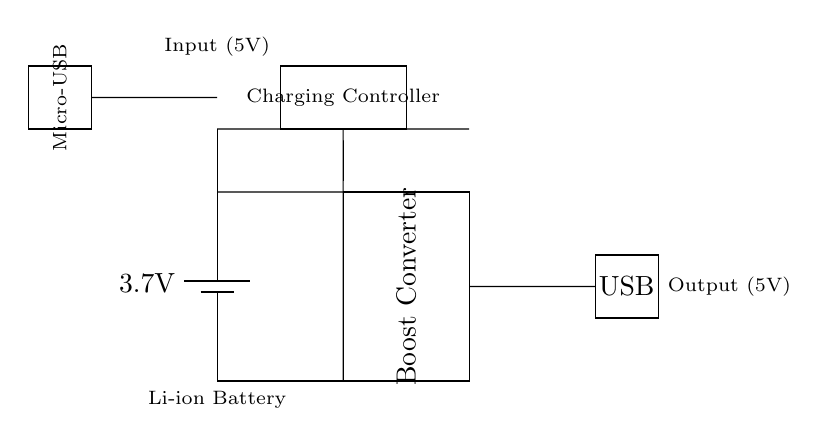What is the input voltage for this circuit? The input voltage is shown at the top of the diagram, labeled as 5V, which is the voltage supplied to the charging controller via the Micro-USB input.
Answer: 5V What component is used to boost the voltage? The circuit contains a Boost Converter, which is specifically indicated within the rectangle in the circuit diagram. This component increases the voltage from the battery to the USB output level.
Answer: Boost Converter How many main components are visible in this circuit? The circuit displays four main components: a battery, a Boost Converter, a Charging Controller, and a USB output, each of which is clearly illustrated.
Answer: Four What type of battery is used in this circuit? The circuit specifies that a Li-ion Battery is used, as it is labeled under the battery symbol at the bottom of the diagram.
Answer: Li-ion Battery What is the output voltage of the USB connection? The output voltage is indicated on the right side of the circuit diagram, labeled as 5V, which is the voltage provided through the USB port for charging devices.
Answer: 5V What is the purpose of the charging controller? The Charging Controller manages the charging process for the Li-ion Battery, ensuring its safe and efficient operation while connected to the input power source, which is essential for reliable functionality.
Answer: Charging management 